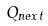<formula> <loc_0><loc_0><loc_500><loc_500>Q _ { n e x t }</formula> 